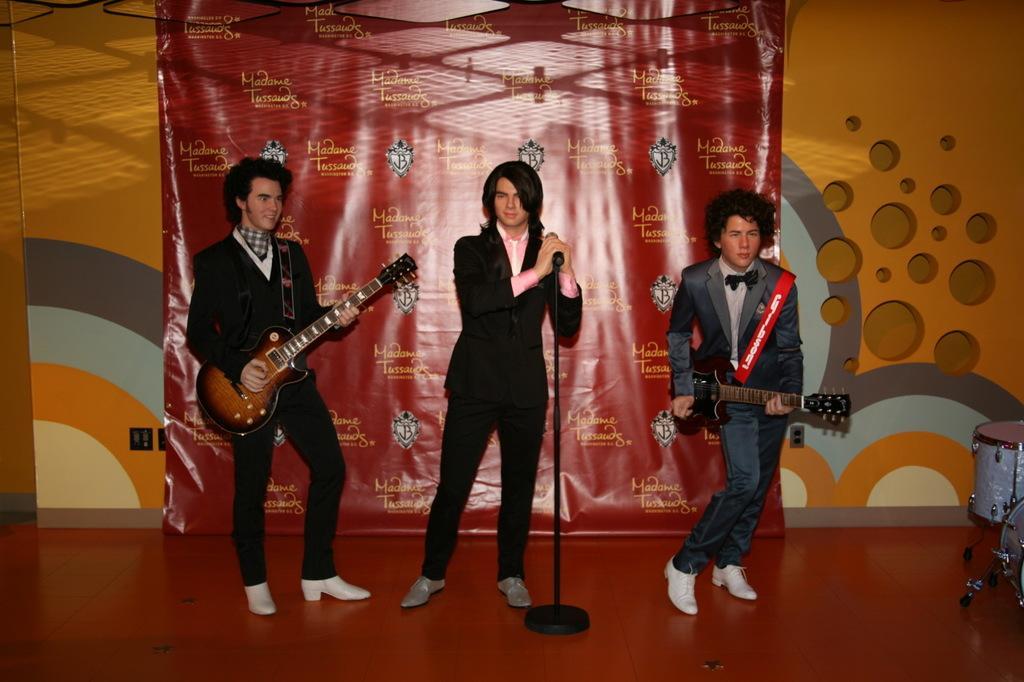Could you give a brief overview of what you see in this image? In this image there are three persons two of them are playing guitar at the middle of the image there is a person standing and holding microphone in his hands and at the right side of the image there are drums and at the background of the image there is a red color sheet and orange color wall. 